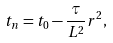<formula> <loc_0><loc_0><loc_500><loc_500>t _ { n } = t _ { 0 } - \frac { \tau } { L ^ { 2 } } r ^ { 2 } ,</formula> 